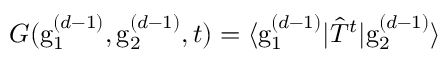Convert formula to latex. <formula><loc_0><loc_0><loc_500><loc_500>G ( g _ { 1 } ^ { ( d - 1 ) } , g _ { 2 } ^ { ( d - 1 ) } , t ) = \langle g _ { 1 } ^ { ( d - 1 ) } | \hat { T } ^ { t } | g _ { 2 } ^ { ( d - 1 ) } \rangle</formula> 